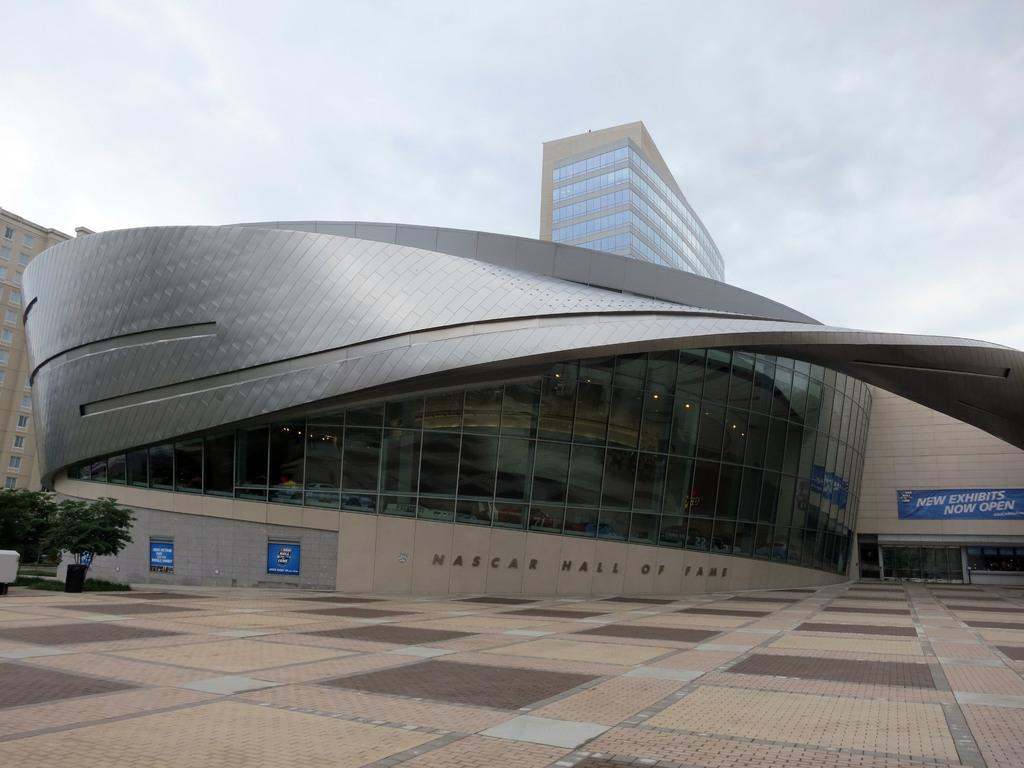<image>
Relay a brief, clear account of the picture shown. New exibits are now open in this building with the big windows 